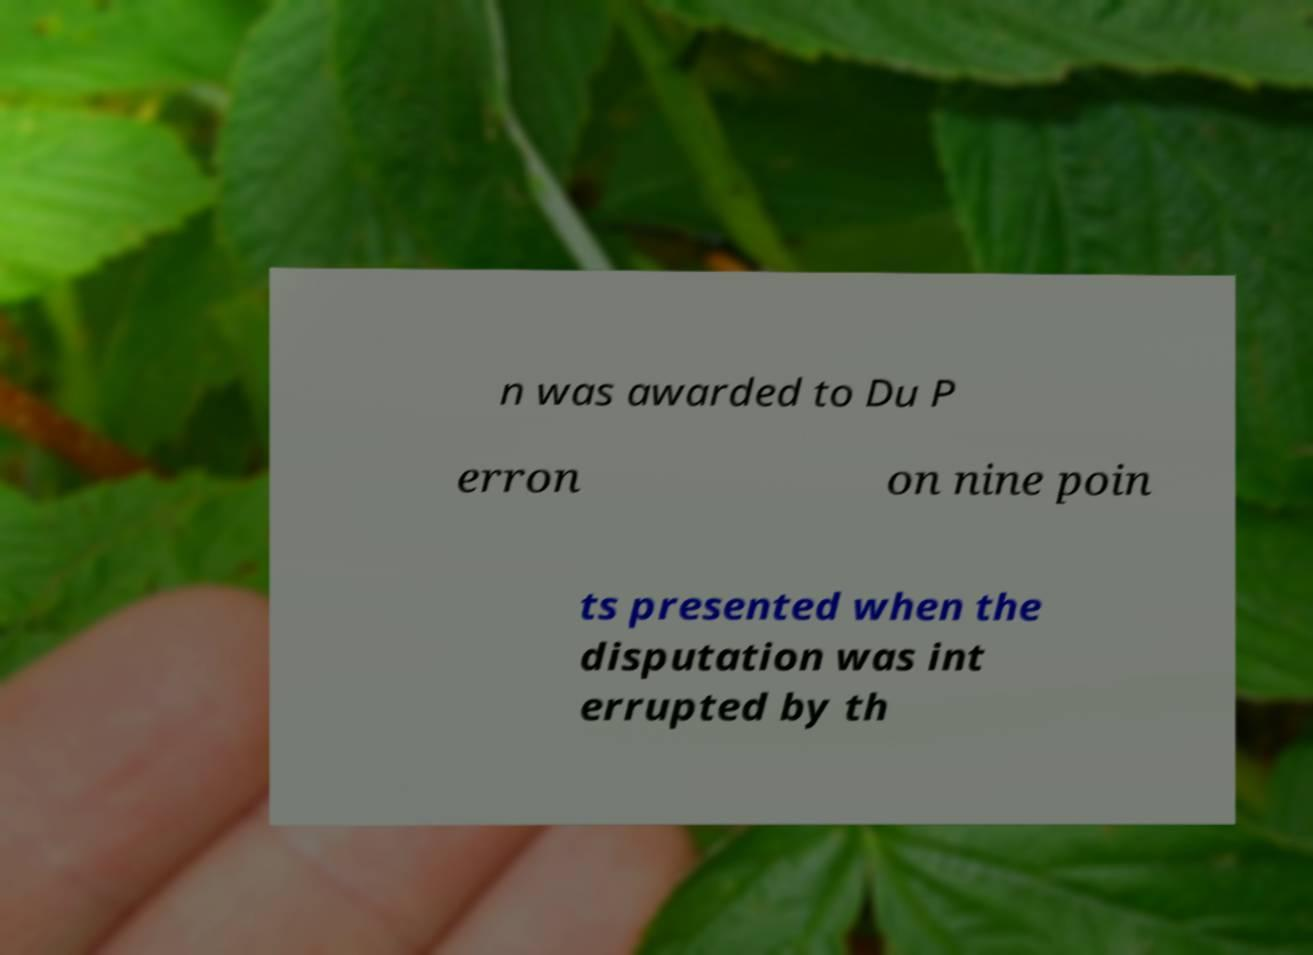For documentation purposes, I need the text within this image transcribed. Could you provide that? n was awarded to Du P erron on nine poin ts presented when the disputation was int errupted by th 